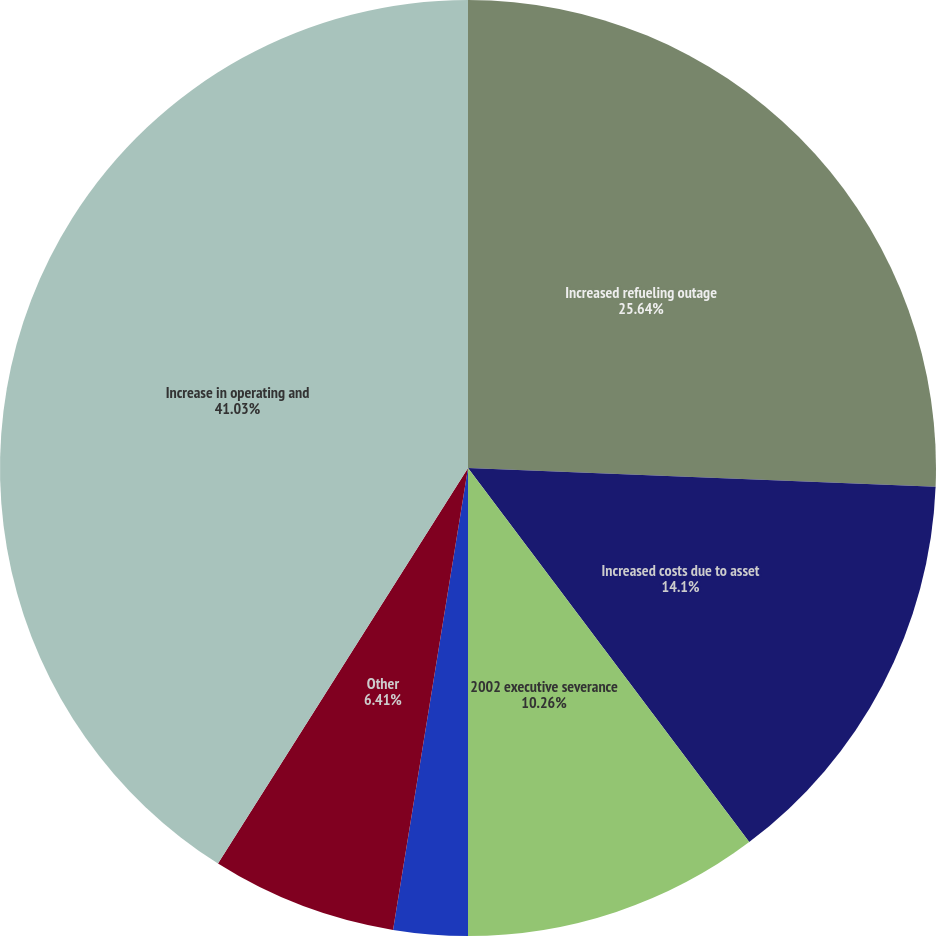Convert chart. <chart><loc_0><loc_0><loc_500><loc_500><pie_chart><fcel>Increased refueling outage<fcel>Increased costs due to asset<fcel>2002 executive severance<fcel>Decreased payroll expense due<fcel>Other<fcel>Increase in operating and<nl><fcel>25.64%<fcel>14.1%<fcel>10.26%<fcel>2.56%<fcel>6.41%<fcel>41.03%<nl></chart> 